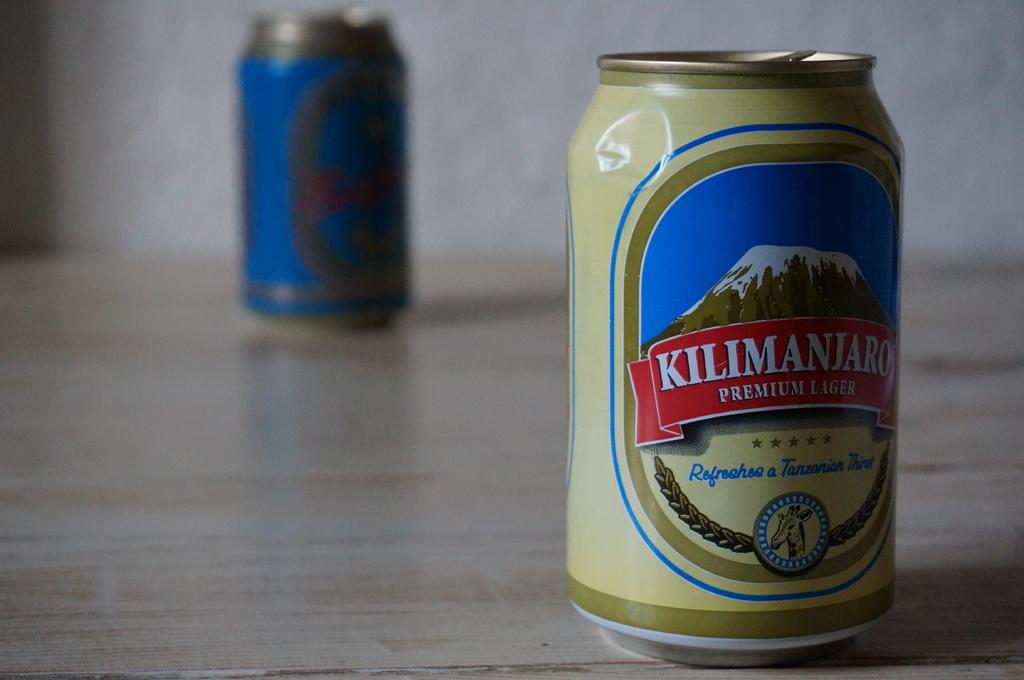Where is kilimanjaro?
Give a very brief answer. Tanzania. 